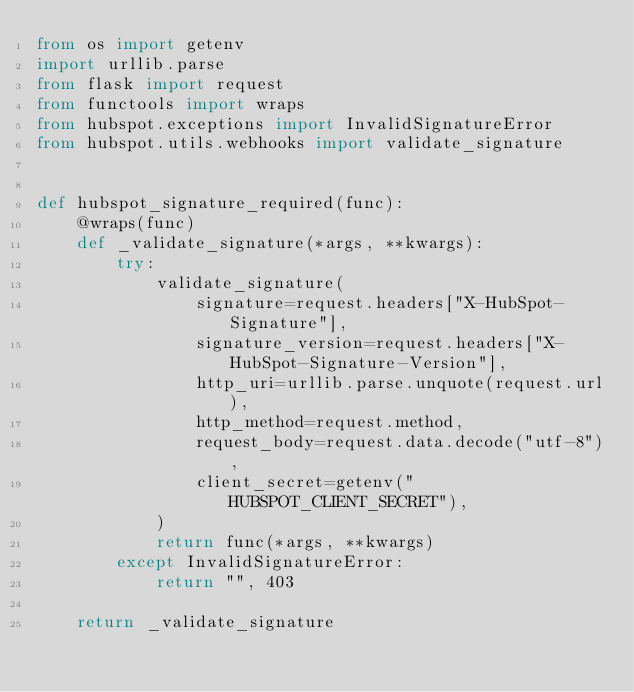<code> <loc_0><loc_0><loc_500><loc_500><_Python_>from os import getenv
import urllib.parse
from flask import request
from functools import wraps
from hubspot.exceptions import InvalidSignatureError
from hubspot.utils.webhooks import validate_signature


def hubspot_signature_required(func):
    @wraps(func)
    def _validate_signature(*args, **kwargs):
        try:
            validate_signature(
                signature=request.headers["X-HubSpot-Signature"],
                signature_version=request.headers["X-HubSpot-Signature-Version"],
                http_uri=urllib.parse.unquote(request.url),
                http_method=request.method,
                request_body=request.data.decode("utf-8"),
                client_secret=getenv("HUBSPOT_CLIENT_SECRET"),
            )
            return func(*args, **kwargs)
        except InvalidSignatureError:
            return "", 403

    return _validate_signature
</code> 